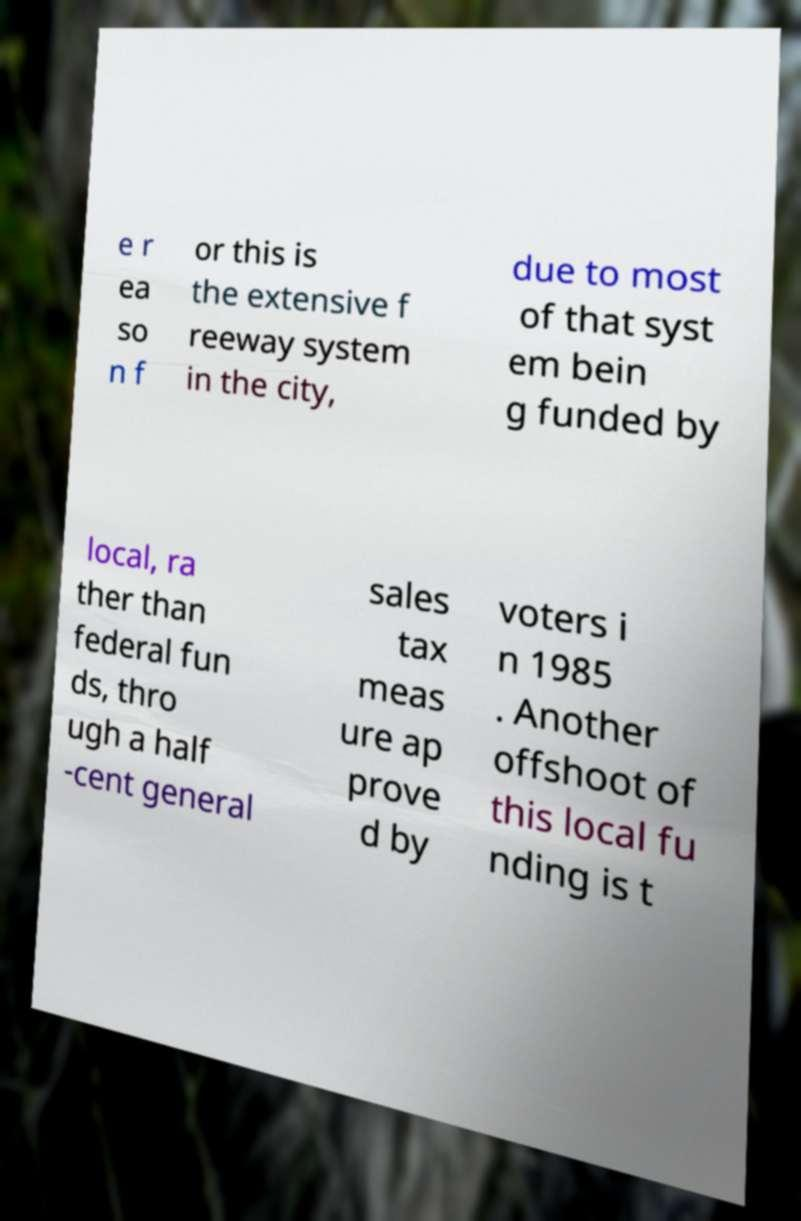For documentation purposes, I need the text within this image transcribed. Could you provide that? e r ea so n f or this is the extensive f reeway system in the city, due to most of that syst em bein g funded by local, ra ther than federal fun ds, thro ugh a half -cent general sales tax meas ure ap prove d by voters i n 1985 . Another offshoot of this local fu nding is t 